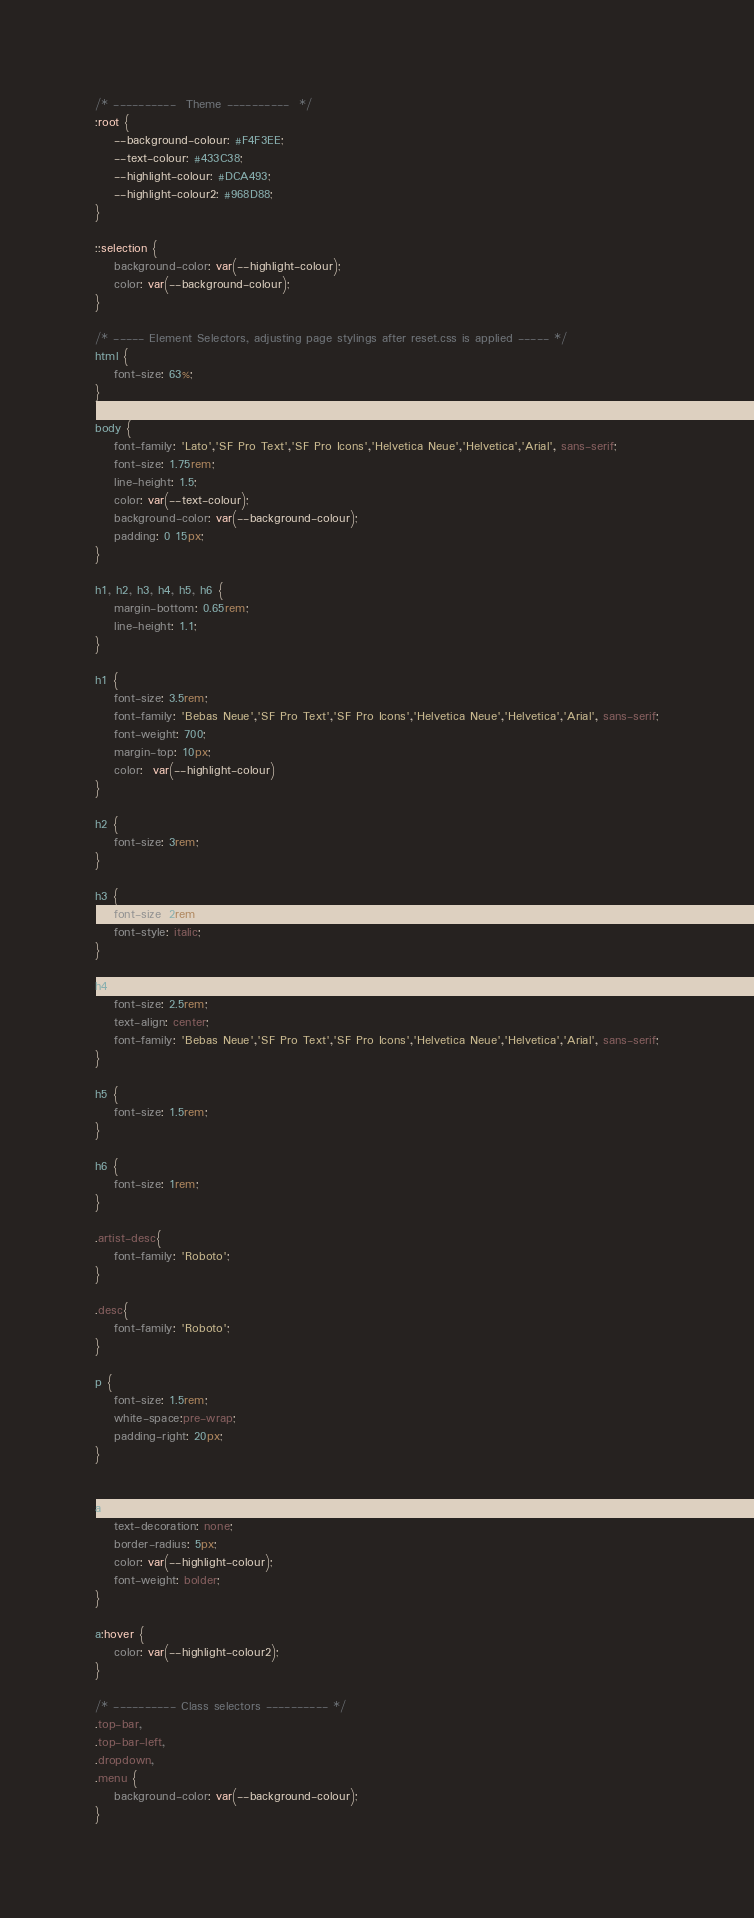Convert code to text. <code><loc_0><loc_0><loc_500><loc_500><_CSS_>/* ----------  Theme ----------  */
:root {
    --background-colour: #F4F3EE;
    --text-colour: #433C38;
    --highlight-colour: #DCA493;
    --highlight-colour2: #968D88;
}

::selection {
    background-color: var(--highlight-colour);
    color: var(--background-colour);
}

/* ----- Element Selectors, adjusting page stylings after reset.css is applied ----- */
html {
    font-size: 63%;
}

body {
    font-family: 'Lato','SF Pro Text','SF Pro Icons','Helvetica Neue','Helvetica','Arial', sans-serif;
    font-size: 1.75rem;
    line-height: 1.5;
    color: var(--text-colour);
    background-color: var(--background-colour);
    padding: 0 15px;
}

h1, h2, h3, h4, h5, h6 {
    margin-bottom: 0.65rem;
    line-height: 1.1;
}

h1 {
    font-size: 3.5rem;
    font-family: 'Bebas Neue','SF Pro Text','SF Pro Icons','Helvetica Neue','Helvetica','Arial', sans-serif;
    font-weight: 700;
    margin-top: 10px;
    color:  var(--highlight-colour)
}

h2 {
    font-size: 3rem;
}

h3 {
    font-size: 2rem;
    font-style: italic;
}

h4 {
    font-size: 2.5rem;
    text-align: center;
    font-family: 'Bebas Neue','SF Pro Text','SF Pro Icons','Helvetica Neue','Helvetica','Arial', sans-serif;
}

h5 {
    font-size: 1.5rem;
}

h6 {
    font-size: 1rem;
}

.artist-desc{
    font-family: 'Roboto';
}

.desc{
    font-family: 'Roboto';
}

p {
    font-size: 1.5rem;
    white-space:pre-wrap;
    padding-right: 20px;
}


a {
    text-decoration: none;
    border-radius: 5px;
    color: var(--highlight-colour);
    font-weight: bolder;
}

a:hover {
    color: var(--highlight-colour2);
}

/* ---------- Class selectors ---------- */
.top-bar,
.top-bar-left,
.dropdown,
.menu {
    background-color: var(--background-colour);
}
</code> 